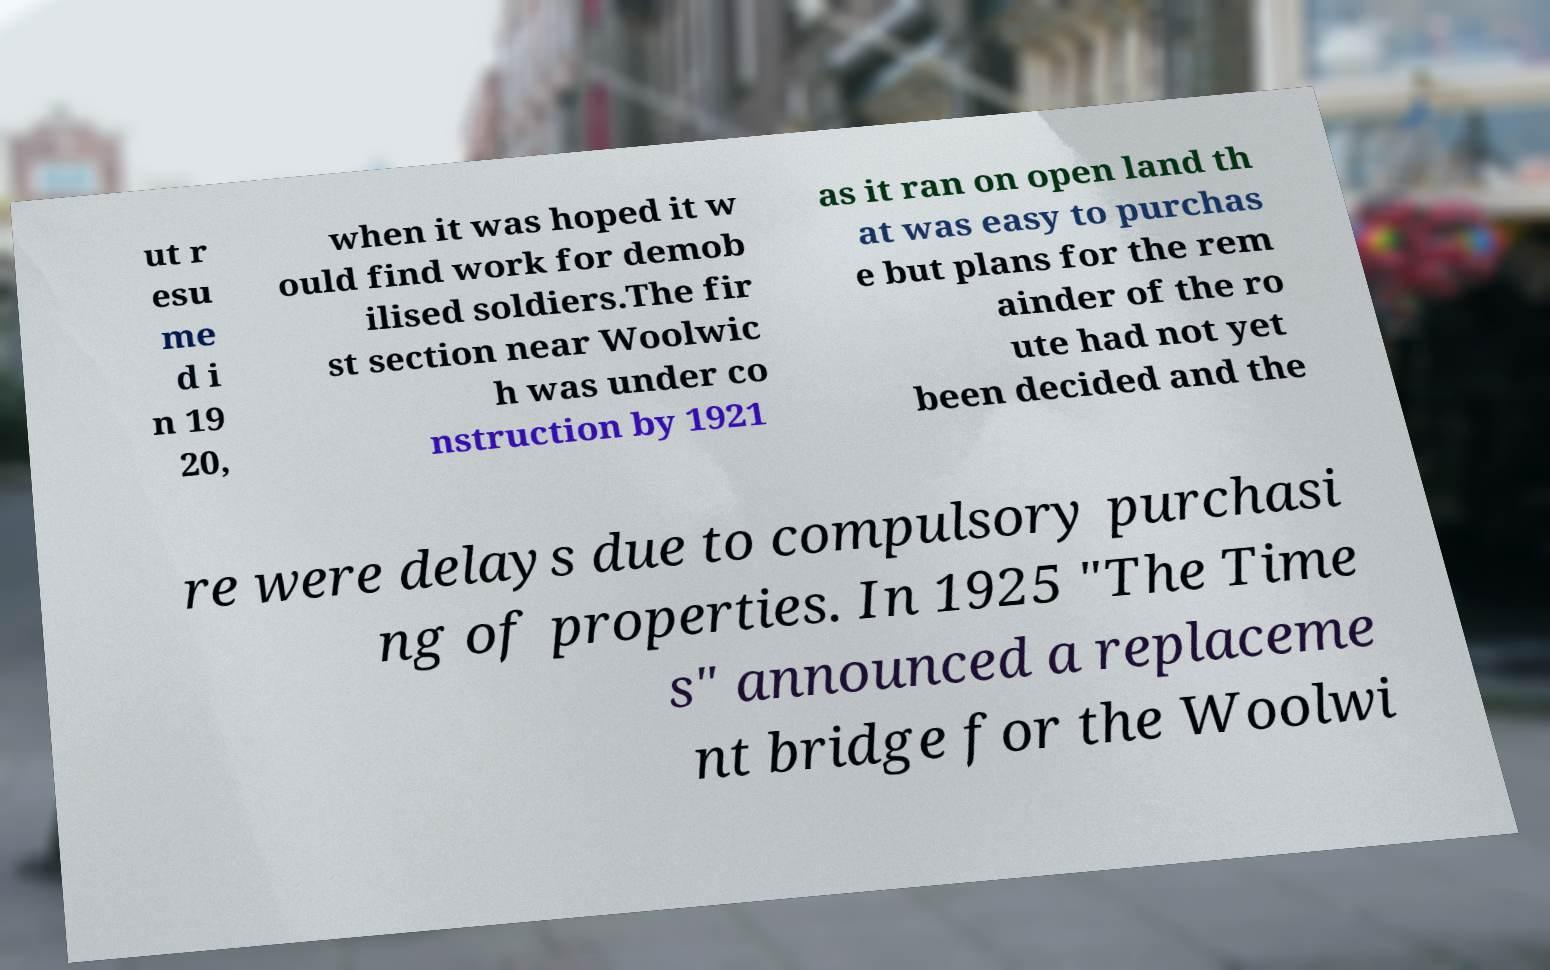Can you read and provide the text displayed in the image?This photo seems to have some interesting text. Can you extract and type it out for me? ut r esu me d i n 19 20, when it was hoped it w ould find work for demob ilised soldiers.The fir st section near Woolwic h was under co nstruction by 1921 as it ran on open land th at was easy to purchas e but plans for the rem ainder of the ro ute had not yet been decided and the re were delays due to compulsory purchasi ng of properties. In 1925 "The Time s" announced a replaceme nt bridge for the Woolwi 